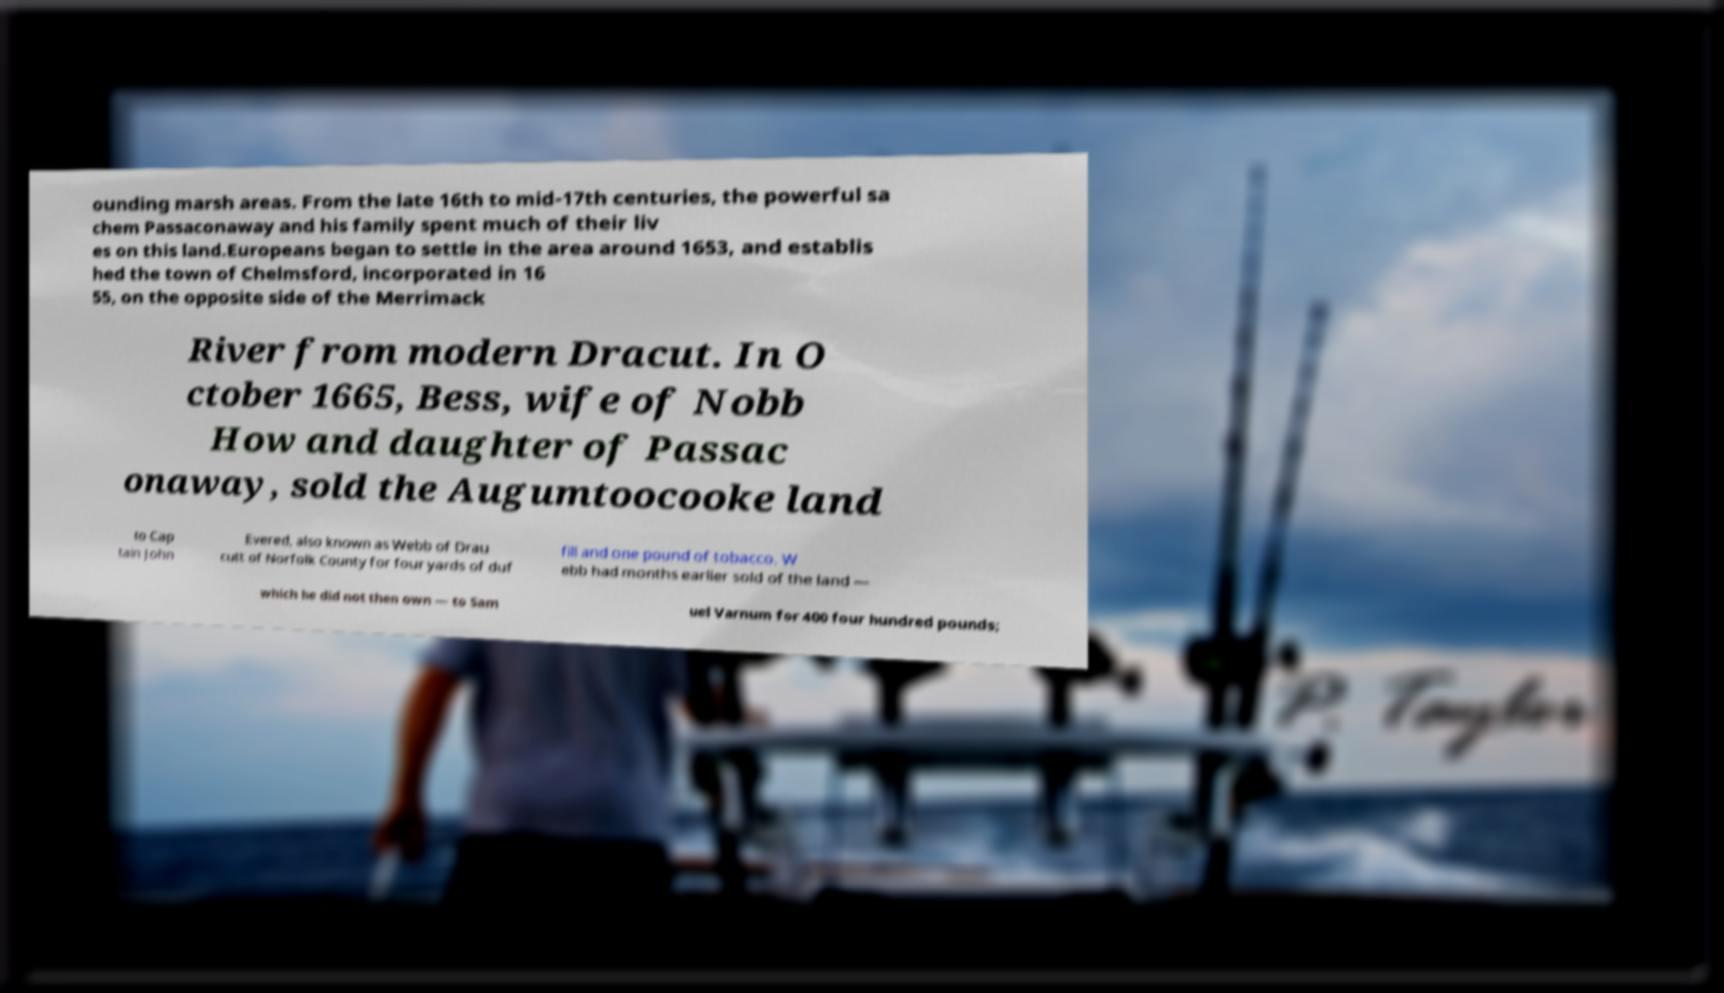Can you accurately transcribe the text from the provided image for me? ounding marsh areas. From the late 16th to mid-17th centuries, the powerful sa chem Passaconaway and his family spent much of their liv es on this land.Europeans began to settle in the area around 1653, and establis hed the town of Chelmsford, incorporated in 16 55, on the opposite side of the Merrimack River from modern Dracut. In O ctober 1665, Bess, wife of Nobb How and daughter of Passac onaway, sold the Augumtoocooke land to Cap tain John Evered, also known as Webb of Drau cutt of Norfolk County for four yards of duf fill and one pound of tobacco. W ebb had months earlier sold of the land — which he did not then own — to Sam uel Varnum for 400 four hundred pounds; 